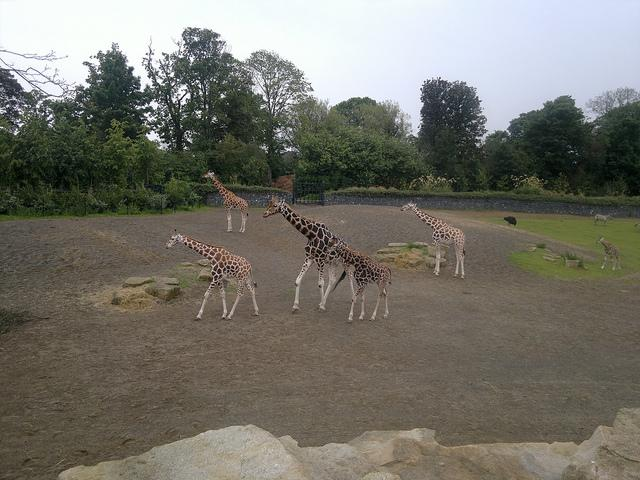What feature do the animals have?

Choices:
A) spots
B) gills
C) wings
D) talons spots 